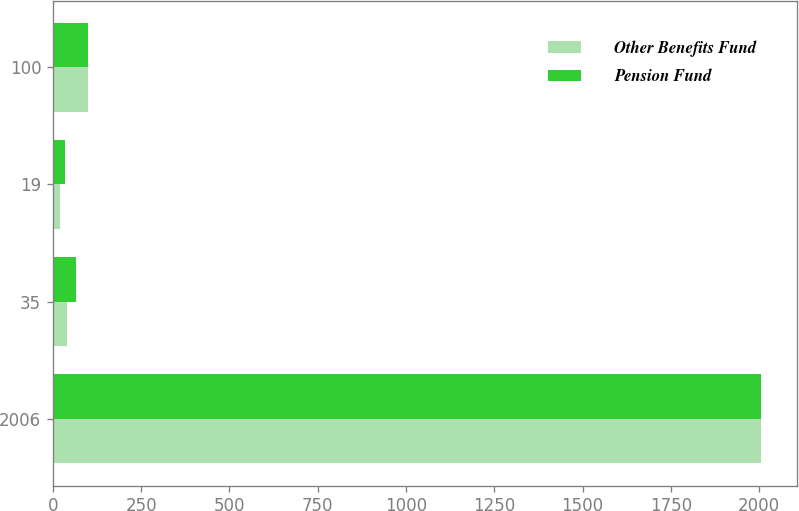Convert chart to OTSL. <chart><loc_0><loc_0><loc_500><loc_500><stacked_bar_chart><ecel><fcel>2006<fcel>35<fcel>19<fcel>100<nl><fcel>Other Benefits Fund<fcel>2005<fcel>39<fcel>19<fcel>100<nl><fcel>Pension Fund<fcel>2006<fcel>66<fcel>34<fcel>100<nl></chart> 